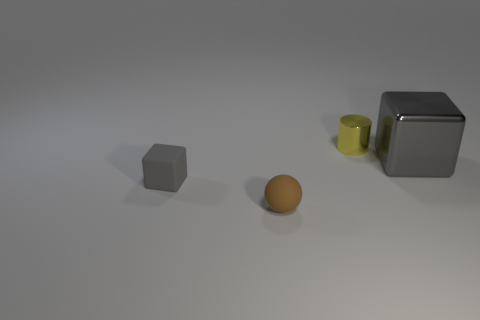There is a rubber cube; is its color the same as the small thing that is behind the large gray metal object?
Your answer should be very brief. No. Are there more large brown metal cylinders than cylinders?
Keep it short and to the point. No. Is there anything else of the same color as the big metal thing?
Ensure brevity in your answer.  Yes. How many other things are there of the same size as the gray rubber thing?
Your answer should be compact. 2. There is a gray block on the right side of the metallic object on the left side of the cube that is to the right of the tiny yellow shiny cylinder; what is its material?
Ensure brevity in your answer.  Metal. Do the brown object and the cube that is left of the large gray block have the same material?
Offer a terse response. Yes. Is the number of small brown things that are left of the gray matte object less than the number of tiny yellow metal objects in front of the gray shiny object?
Your answer should be compact. No. What number of gray blocks are the same material as the big object?
Give a very brief answer. 0. There is a small metallic object that is behind the gray block left of the yellow thing; are there any metal cubes that are left of it?
Provide a short and direct response. No. What number of spheres are small purple objects or shiny things?
Your answer should be compact. 0. 